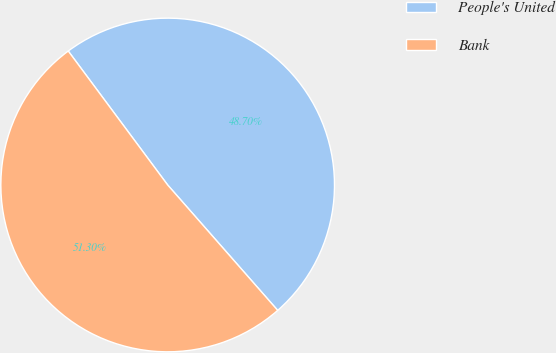<chart> <loc_0><loc_0><loc_500><loc_500><pie_chart><fcel>People's United<fcel>Bank<nl><fcel>48.7%<fcel>51.3%<nl></chart> 